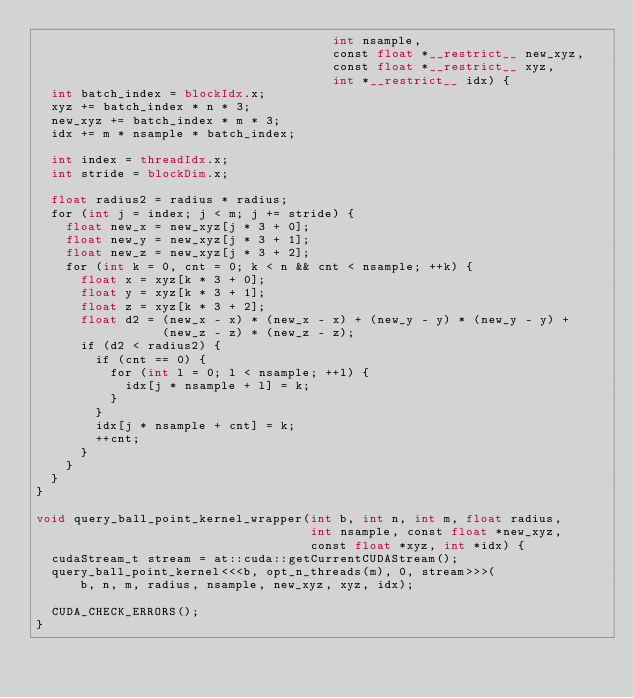Convert code to text. <code><loc_0><loc_0><loc_500><loc_500><_Cuda_>                                        int nsample,
                                        const float *__restrict__ new_xyz,
                                        const float *__restrict__ xyz,
                                        int *__restrict__ idx) {
  int batch_index = blockIdx.x;
  xyz += batch_index * n * 3;
  new_xyz += batch_index * m * 3;
  idx += m * nsample * batch_index;

  int index = threadIdx.x;
  int stride = blockDim.x;

  float radius2 = radius * radius;
  for (int j = index; j < m; j += stride) {
    float new_x = new_xyz[j * 3 + 0];
    float new_y = new_xyz[j * 3 + 1];
    float new_z = new_xyz[j * 3 + 2];
    for (int k = 0, cnt = 0; k < n && cnt < nsample; ++k) {
      float x = xyz[k * 3 + 0];
      float y = xyz[k * 3 + 1];
      float z = xyz[k * 3 + 2];
      float d2 = (new_x - x) * (new_x - x) + (new_y - y) * (new_y - y) +
                 (new_z - z) * (new_z - z);
      if (d2 < radius2) {
        if (cnt == 0) {
          for (int l = 0; l < nsample; ++l) {
            idx[j * nsample + l] = k;
          }
        }
        idx[j * nsample + cnt] = k;
        ++cnt;
      }
    }
  }
}

void query_ball_point_kernel_wrapper(int b, int n, int m, float radius,
                                     int nsample, const float *new_xyz,
                                     const float *xyz, int *idx) {
  cudaStream_t stream = at::cuda::getCurrentCUDAStream();
  query_ball_point_kernel<<<b, opt_n_threads(m), 0, stream>>>(
      b, n, m, radius, nsample, new_xyz, xyz, idx);

  CUDA_CHECK_ERRORS();
}
</code> 